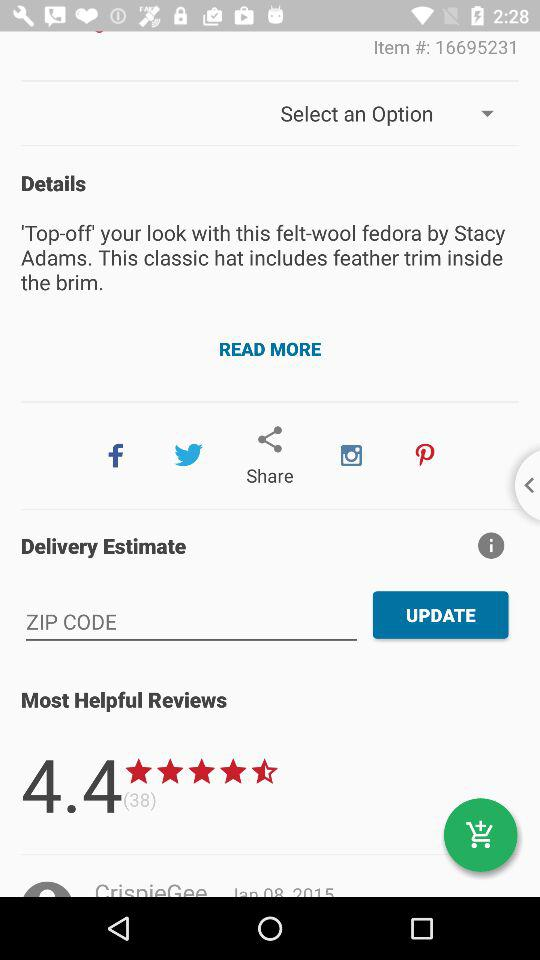What is the item's rating? The item's rating is 4.4 stars. 